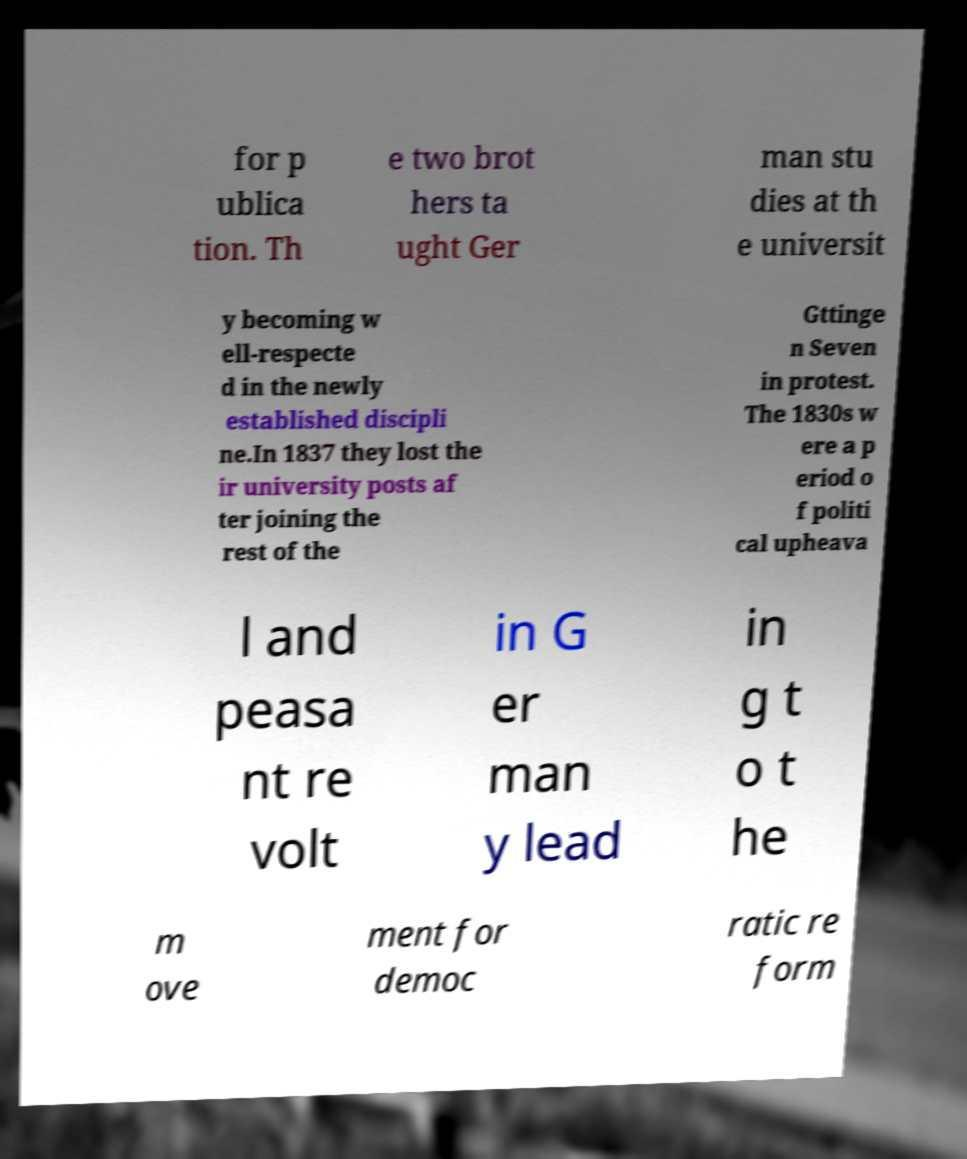There's text embedded in this image that I need extracted. Can you transcribe it verbatim? for p ublica tion. Th e two brot hers ta ught Ger man stu dies at th e universit y becoming w ell-respecte d in the newly established discipli ne.In 1837 they lost the ir university posts af ter joining the rest of the Gttinge n Seven in protest. The 1830s w ere a p eriod o f politi cal upheava l and peasa nt re volt in G er man y lead in g t o t he m ove ment for democ ratic re form 